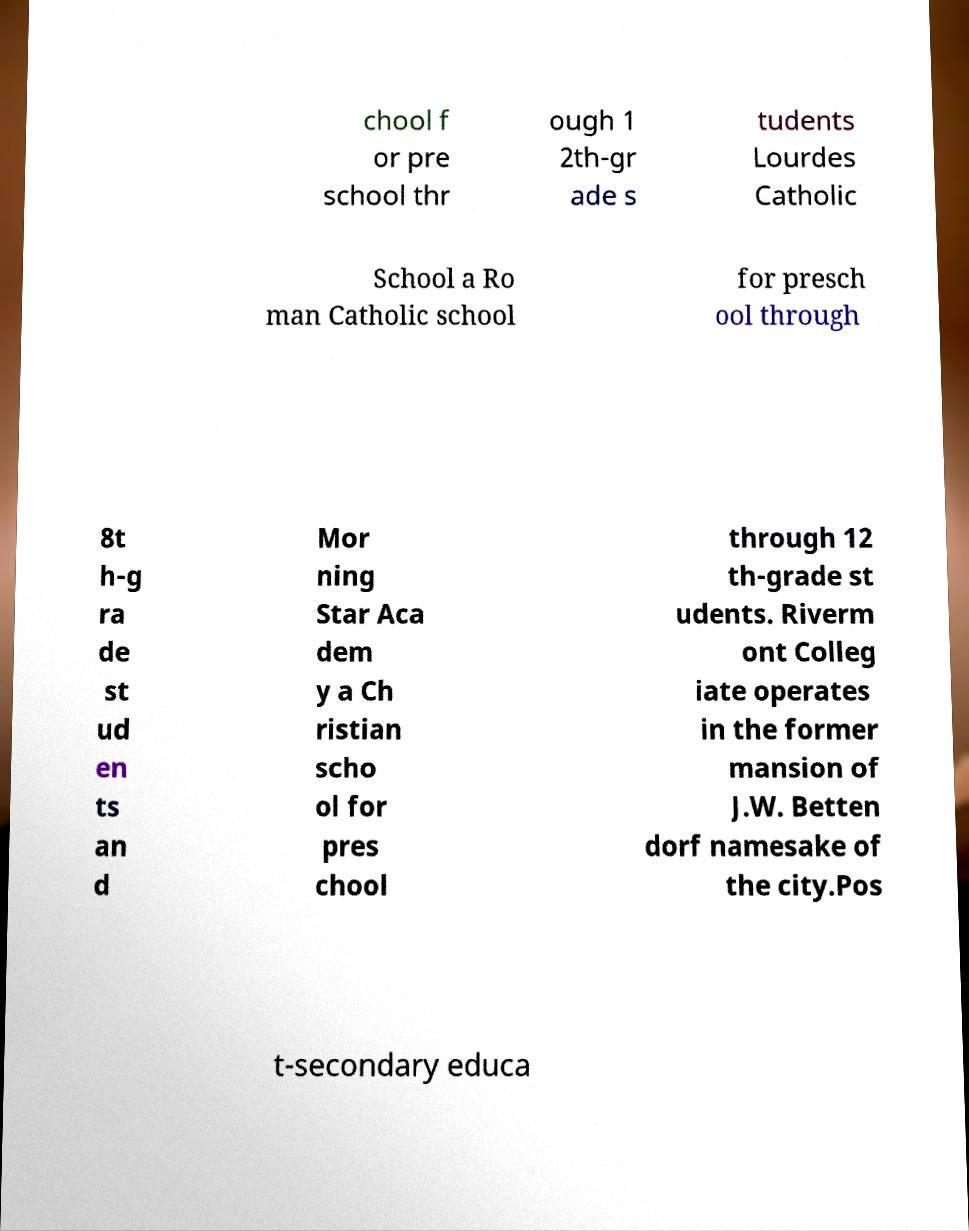Can you accurately transcribe the text from the provided image for me? chool f or pre school thr ough 1 2th-gr ade s tudents Lourdes Catholic School a Ro man Catholic school for presch ool through 8t h-g ra de st ud en ts an d Mor ning Star Aca dem y a Ch ristian scho ol for pres chool through 12 th-grade st udents. Riverm ont Colleg iate operates in the former mansion of J.W. Betten dorf namesake of the city.Pos t-secondary educa 